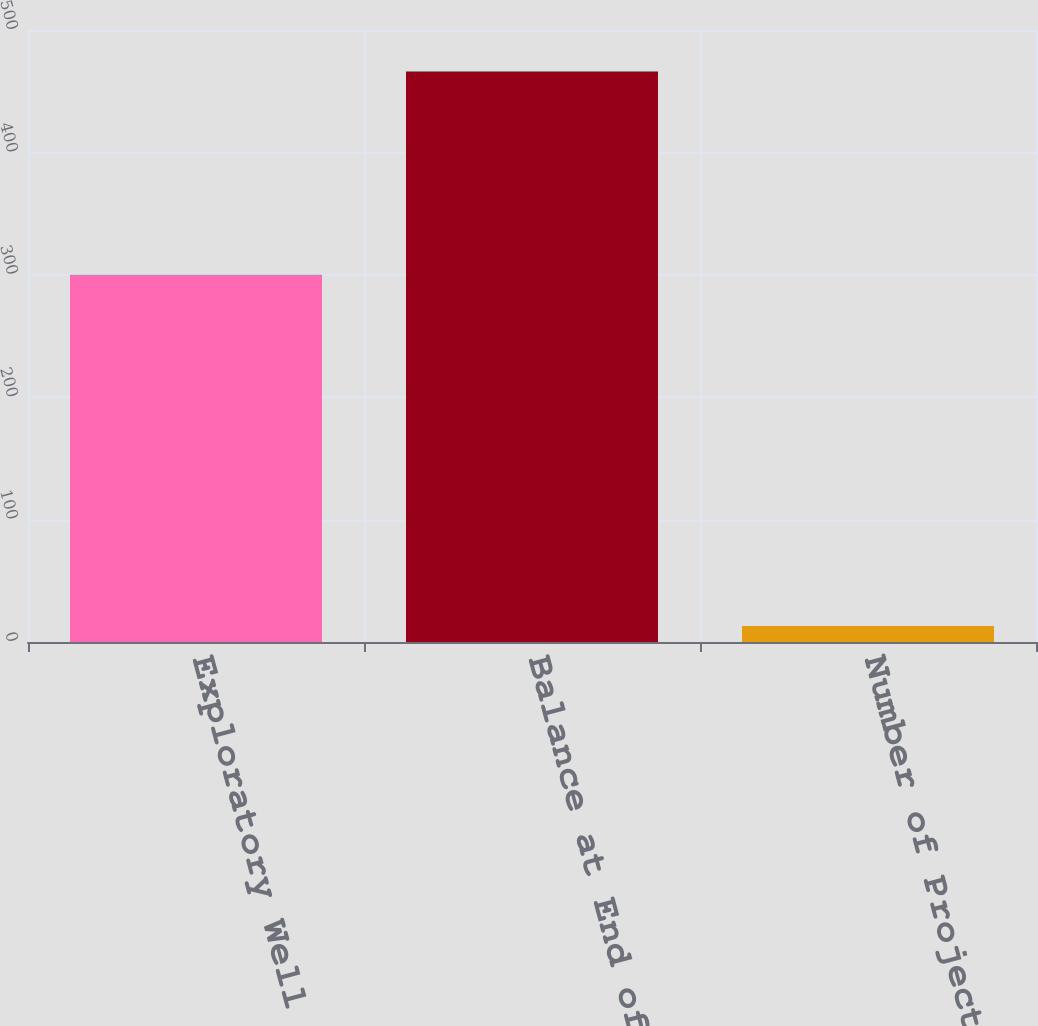<chart> <loc_0><loc_0><loc_500><loc_500><bar_chart><fcel>Exploratory Well Costs<fcel>Balance at End of Period<fcel>Number of Projects with<nl><fcel>300<fcel>466<fcel>13<nl></chart> 